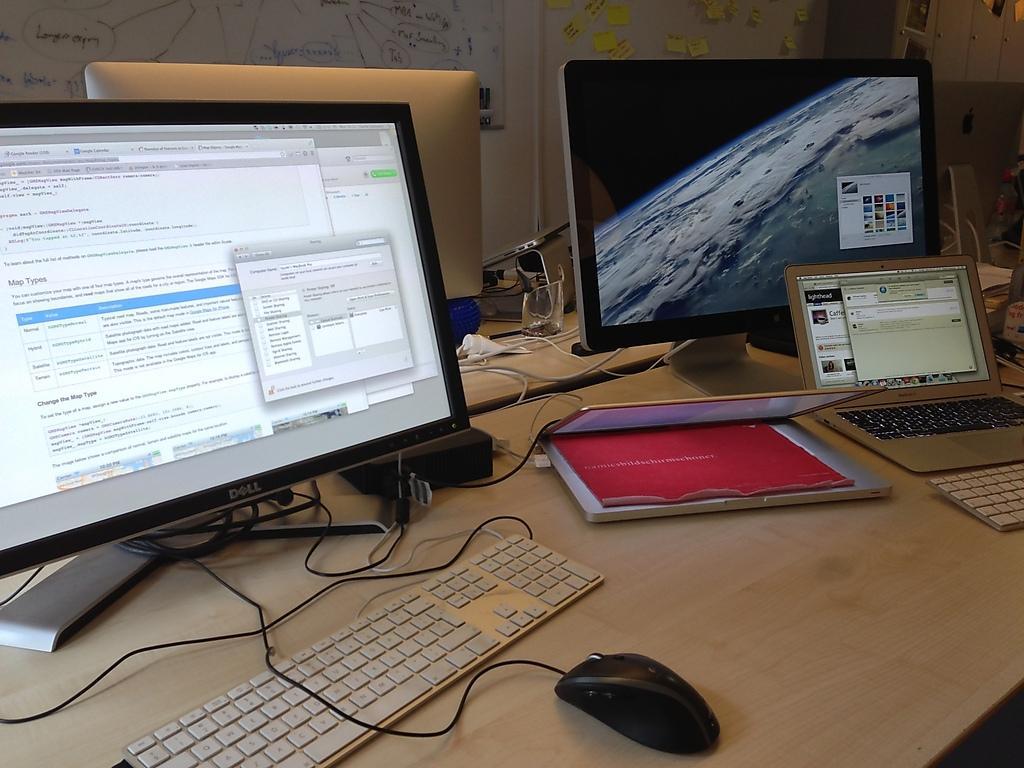Please provide a concise description of this image. This image is clicked in a room where it has tables ,on that tables there is system, keyboard, mouse ,laptops ,Glass on that. There are wires in the middle. There are white boards on the top. There is written something on that white boards. 